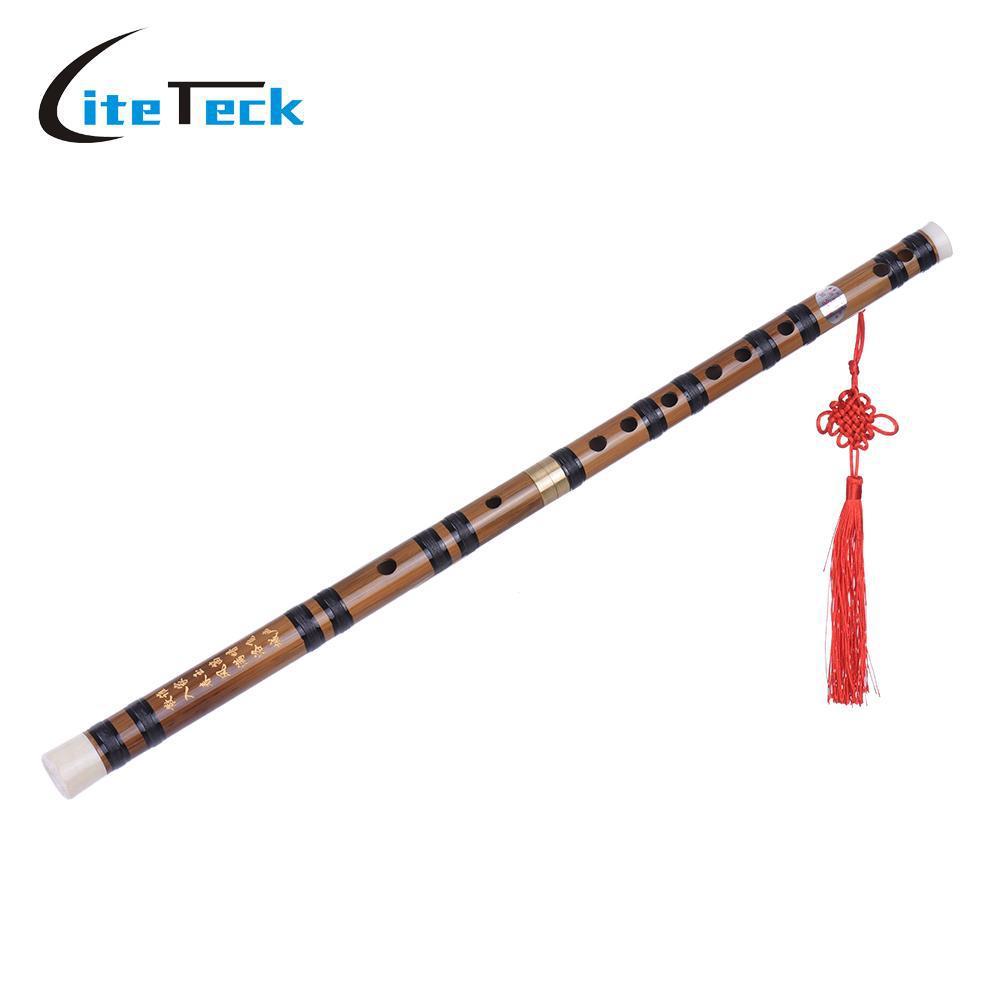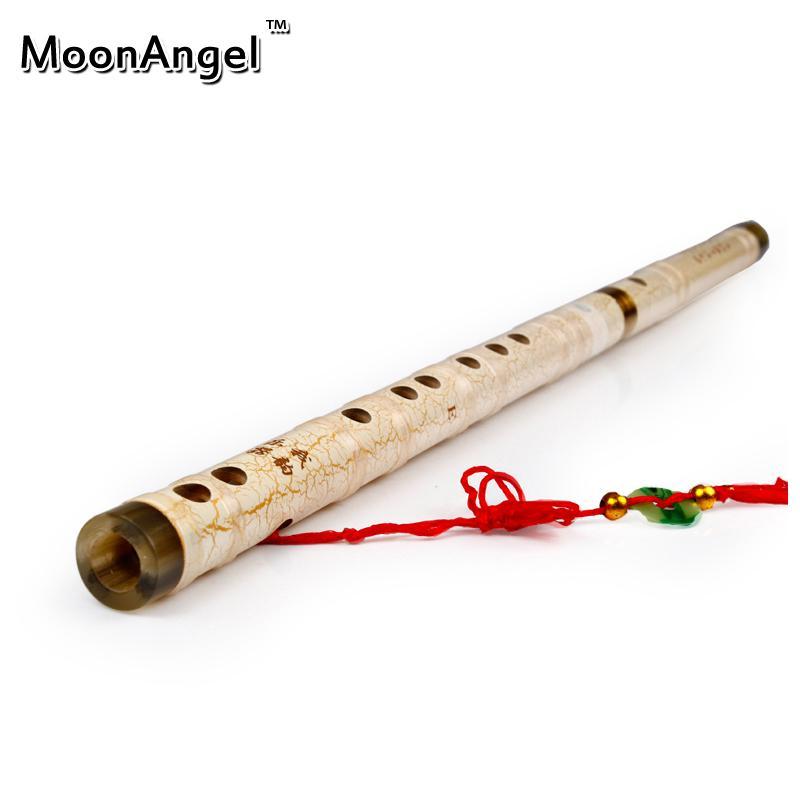The first image is the image on the left, the second image is the image on the right. Given the left and right images, does the statement "Each image contains one flute, which is displayed horizontally and has a red tassel at one end." hold true? Answer yes or no. Yes. The first image is the image on the left, the second image is the image on the right. Examine the images to the left and right. Is the description "The left and right image contains the same number of flutes with red tassels." accurate? Answer yes or no. Yes. 